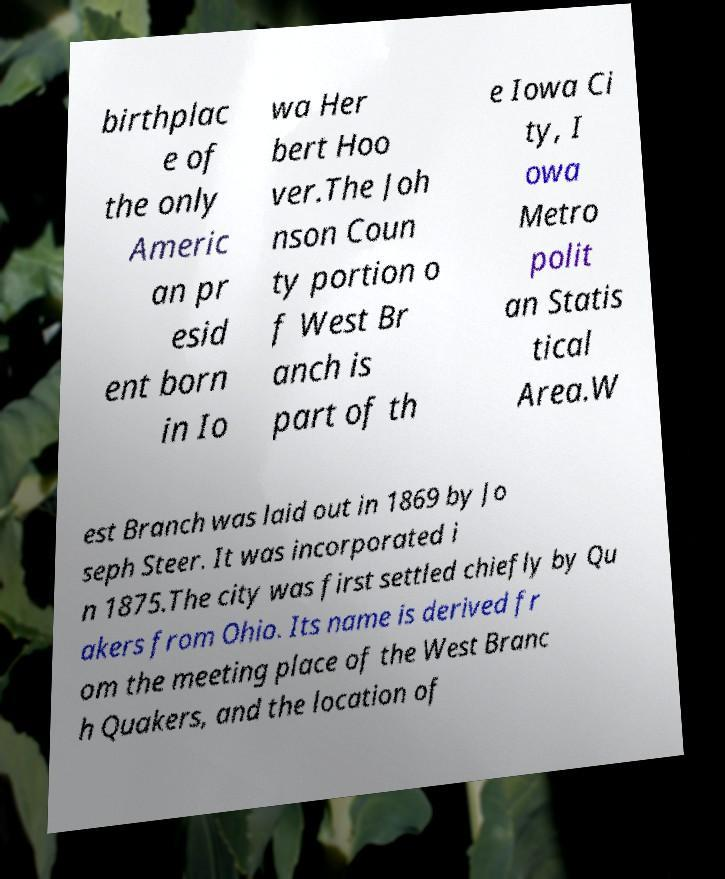Could you assist in decoding the text presented in this image and type it out clearly? birthplac e of the only Americ an pr esid ent born in Io wa Her bert Hoo ver.The Joh nson Coun ty portion o f West Br anch is part of th e Iowa Ci ty, I owa Metro polit an Statis tical Area.W est Branch was laid out in 1869 by Jo seph Steer. It was incorporated i n 1875.The city was first settled chiefly by Qu akers from Ohio. Its name is derived fr om the meeting place of the West Branc h Quakers, and the location of 